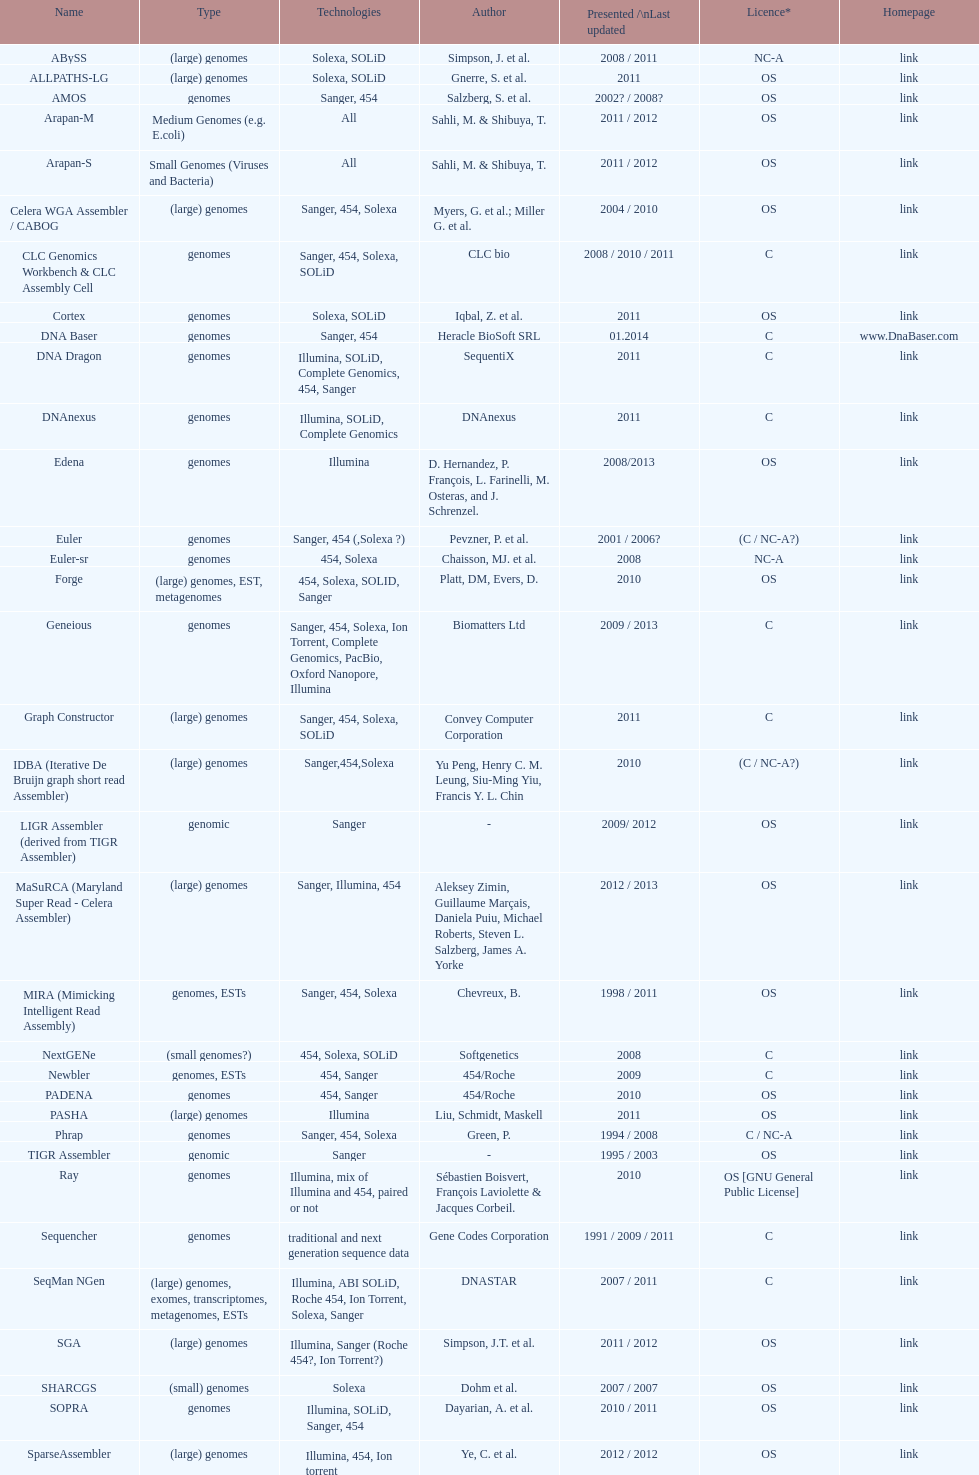What is the total number of assemblers supporting medium genomes type technologies? 1. 